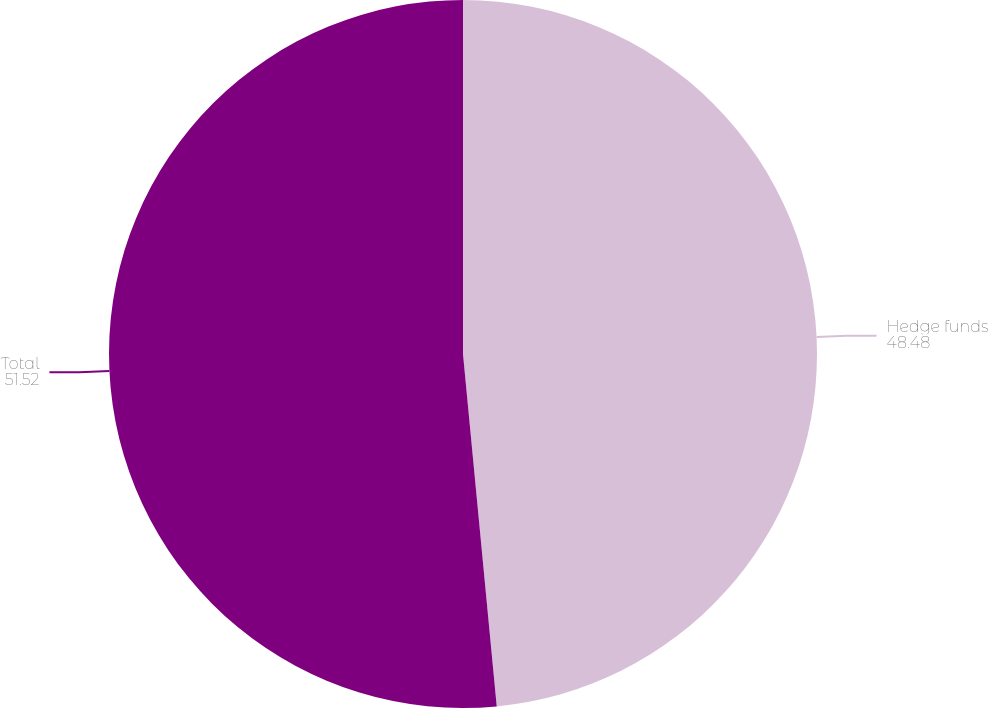<chart> <loc_0><loc_0><loc_500><loc_500><pie_chart><fcel>Hedge funds<fcel>Total<nl><fcel>48.48%<fcel>51.52%<nl></chart> 